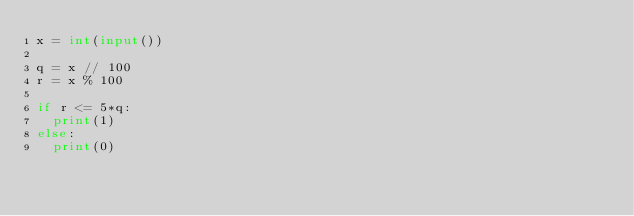<code> <loc_0><loc_0><loc_500><loc_500><_Python_>x = int(input())
 
q = x // 100
r = x % 100
 
if r <= 5*q:
  print(1)
else:
  print(0)</code> 